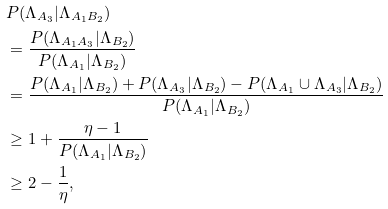<formula> <loc_0><loc_0><loc_500><loc_500>& P ( \Lambda _ { A _ { 3 } } | \Lambda _ { A _ { 1 } B _ { 2 } } ) \\ & = \frac { P ( \Lambda _ { A _ { 1 } A _ { 3 } } | \Lambda _ { B _ { 2 } } ) } { P ( \Lambda _ { A _ { 1 } } | \Lambda _ { B _ { 2 } } ) } \\ & = \frac { P ( \Lambda _ { A _ { 1 } } | \Lambda _ { B _ { 2 } } ) + P ( \Lambda _ { A _ { 3 } } | \Lambda _ { B _ { 2 } } ) - P ( \Lambda _ { A _ { 1 } } \cup \Lambda _ { A _ { 3 } } | \Lambda _ { B _ { 2 } } ) } { P ( \Lambda _ { A _ { 1 } } | \Lambda _ { B _ { 2 } } ) } \\ & \geq 1 + \frac { \eta - 1 } { P ( \Lambda _ { A _ { 1 } } | \Lambda _ { B _ { 2 } } ) } \\ & \geq 2 - \frac { 1 } { \eta } ,</formula> 